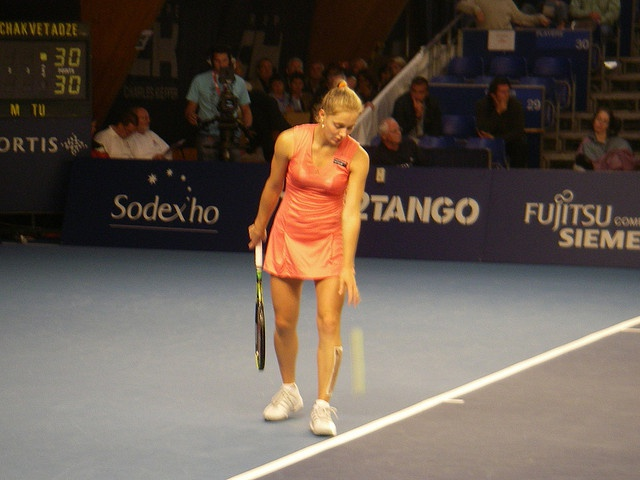Describe the objects in this image and their specific colors. I can see people in black, orange, brown, red, and salmon tones, people in black, maroon, and gray tones, people in black, gray, and maroon tones, people in black and maroon tones, and people in black, maroon, and brown tones in this image. 